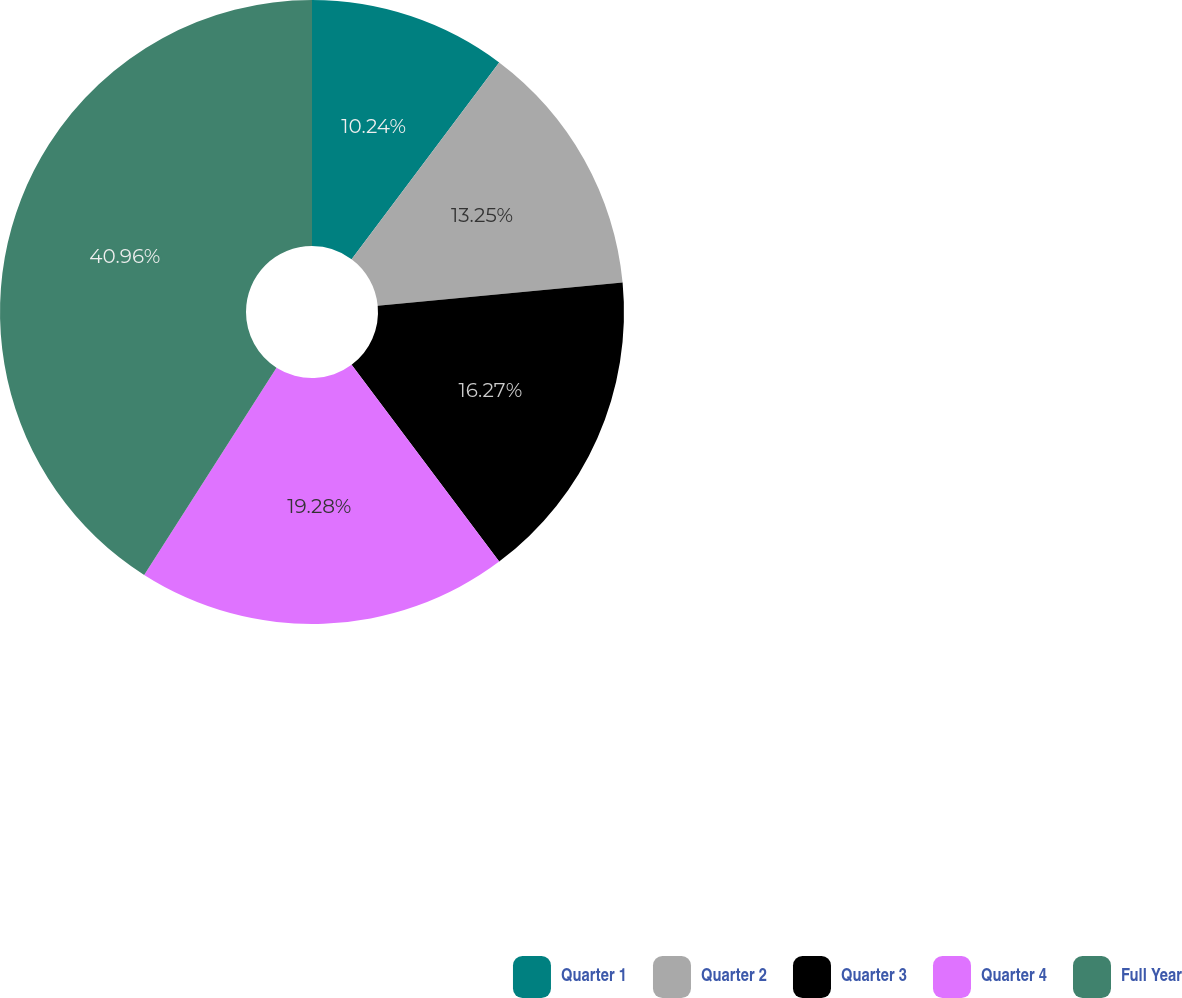<chart> <loc_0><loc_0><loc_500><loc_500><pie_chart><fcel>Quarter 1<fcel>Quarter 2<fcel>Quarter 3<fcel>Quarter 4<fcel>Full Year<nl><fcel>10.24%<fcel>13.25%<fcel>16.27%<fcel>19.28%<fcel>40.96%<nl></chart> 